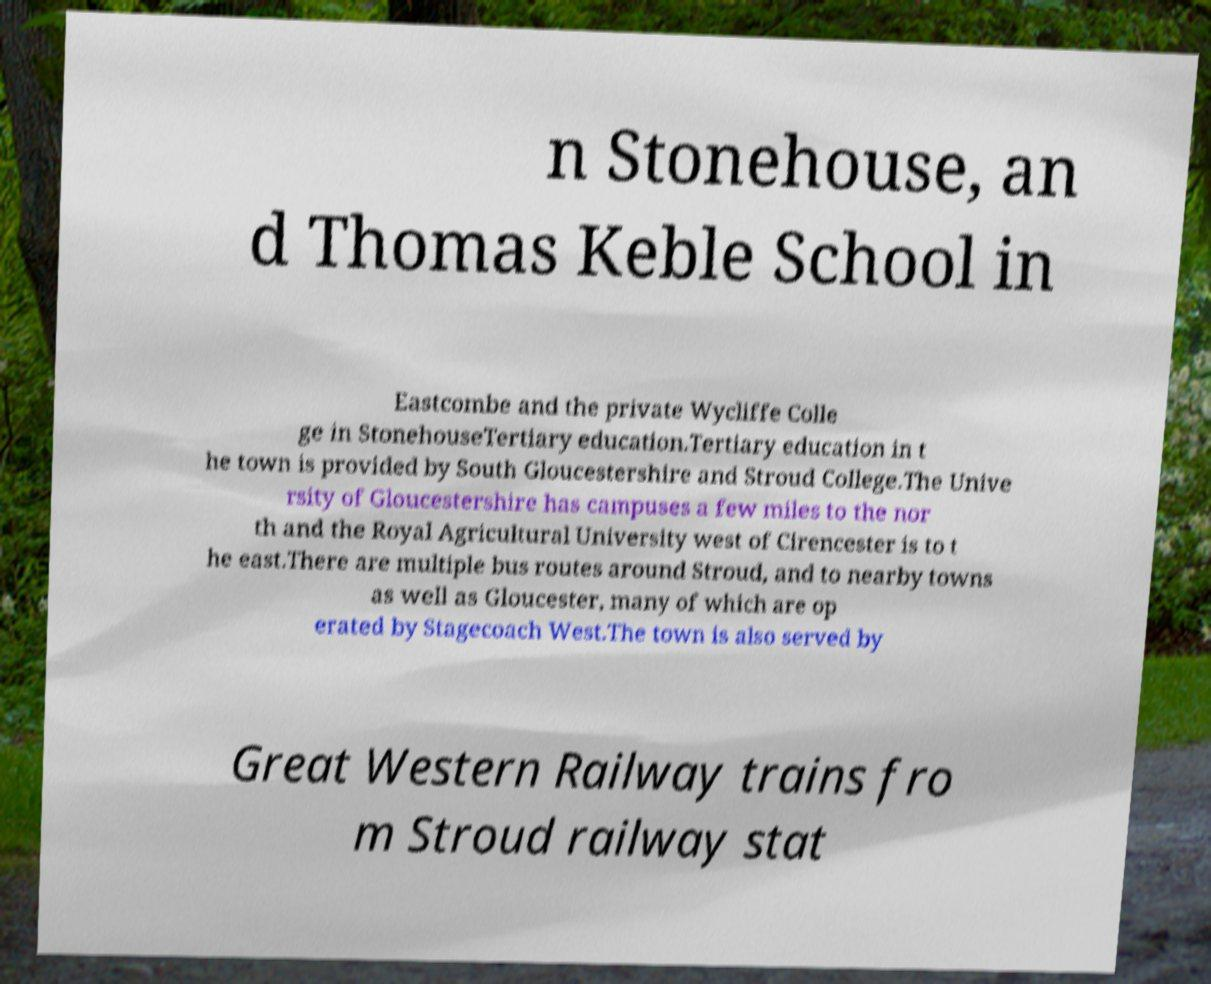Could you assist in decoding the text presented in this image and type it out clearly? n Stonehouse, an d Thomas Keble School in Eastcombe and the private Wycliffe Colle ge in StonehouseTertiary education.Tertiary education in t he town is provided by South Gloucestershire and Stroud College.The Unive rsity of Gloucestershire has campuses a few miles to the nor th and the Royal Agricultural University west of Cirencester is to t he east.There are multiple bus routes around Stroud, and to nearby towns as well as Gloucester, many of which are op erated by Stagecoach West.The town is also served by Great Western Railway trains fro m Stroud railway stat 